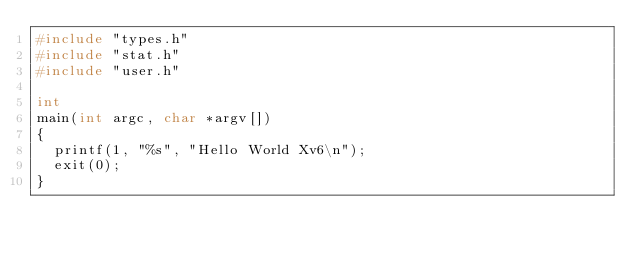Convert code to text. <code><loc_0><loc_0><loc_500><loc_500><_C_>#include "types.h"
#include "stat.h"
#include "user.h"

int
main(int argc, char *argv[])
{
  printf(1, "%s", "Hello World Xv6\n");
  exit(0);
}
</code> 